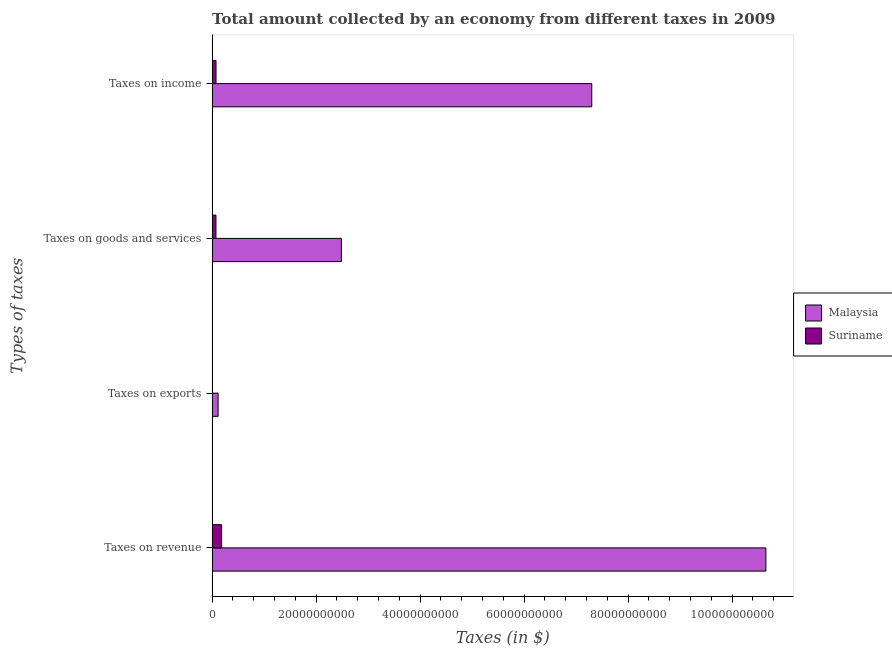How many different coloured bars are there?
Your answer should be compact. 2. How many groups of bars are there?
Make the answer very short. 4. What is the label of the 4th group of bars from the top?
Your answer should be compact. Taxes on revenue. What is the amount collected as tax on revenue in Suriname?
Offer a very short reply. 1.83e+09. Across all countries, what is the maximum amount collected as tax on income?
Make the answer very short. 7.30e+1. Across all countries, what is the minimum amount collected as tax on revenue?
Your answer should be compact. 1.83e+09. In which country was the amount collected as tax on goods maximum?
Provide a short and direct response. Malaysia. In which country was the amount collected as tax on exports minimum?
Provide a succinct answer. Suriname. What is the total amount collected as tax on exports in the graph?
Offer a very short reply. 1.16e+09. What is the difference between the amount collected as tax on goods in Suriname and that in Malaysia?
Provide a short and direct response. -2.41e+1. What is the difference between the amount collected as tax on revenue in Malaysia and the amount collected as tax on exports in Suriname?
Keep it short and to the point. 1.07e+11. What is the average amount collected as tax on goods per country?
Provide a short and direct response. 1.28e+1. What is the difference between the amount collected as tax on exports and amount collected as tax on income in Malaysia?
Provide a short and direct response. -7.19e+1. In how many countries, is the amount collected as tax on income greater than 36000000000 $?
Your answer should be compact. 1. What is the ratio of the amount collected as tax on exports in Malaysia to that in Suriname?
Keep it short and to the point. 269.78. Is the difference between the amount collected as tax on exports in Suriname and Malaysia greater than the difference between the amount collected as tax on goods in Suriname and Malaysia?
Make the answer very short. Yes. What is the difference between the highest and the second highest amount collected as tax on income?
Give a very brief answer. 7.23e+1. What is the difference between the highest and the lowest amount collected as tax on revenue?
Ensure brevity in your answer.  1.05e+11. Is the sum of the amount collected as tax on goods in Malaysia and Suriname greater than the maximum amount collected as tax on revenue across all countries?
Your answer should be compact. No. What does the 1st bar from the top in Taxes on exports represents?
Offer a terse response. Suriname. What does the 1st bar from the bottom in Taxes on exports represents?
Give a very brief answer. Malaysia. Is it the case that in every country, the sum of the amount collected as tax on revenue and amount collected as tax on exports is greater than the amount collected as tax on goods?
Offer a very short reply. Yes. Are all the bars in the graph horizontal?
Give a very brief answer. Yes. Are the values on the major ticks of X-axis written in scientific E-notation?
Provide a succinct answer. No. Does the graph contain any zero values?
Keep it short and to the point. No. How are the legend labels stacked?
Give a very brief answer. Vertical. What is the title of the graph?
Offer a very short reply. Total amount collected by an economy from different taxes in 2009. Does "Belarus" appear as one of the legend labels in the graph?
Offer a very short reply. No. What is the label or title of the X-axis?
Offer a terse response. Taxes (in $). What is the label or title of the Y-axis?
Give a very brief answer. Types of taxes. What is the Taxes (in $) in Malaysia in Taxes on revenue?
Offer a very short reply. 1.07e+11. What is the Taxes (in $) in Suriname in Taxes on revenue?
Offer a terse response. 1.83e+09. What is the Taxes (in $) of Malaysia in Taxes on exports?
Provide a succinct answer. 1.15e+09. What is the Taxes (in $) of Suriname in Taxes on exports?
Keep it short and to the point. 4.27e+06. What is the Taxes (in $) of Malaysia in Taxes on goods and services?
Offer a terse response. 2.49e+1. What is the Taxes (in $) in Suriname in Taxes on goods and services?
Offer a very short reply. 7.38e+08. What is the Taxes (in $) in Malaysia in Taxes on income?
Make the answer very short. 7.30e+1. What is the Taxes (in $) of Suriname in Taxes on income?
Provide a short and direct response. 7.49e+08. Across all Types of taxes, what is the maximum Taxes (in $) of Malaysia?
Your answer should be very brief. 1.07e+11. Across all Types of taxes, what is the maximum Taxes (in $) of Suriname?
Make the answer very short. 1.83e+09. Across all Types of taxes, what is the minimum Taxes (in $) of Malaysia?
Make the answer very short. 1.15e+09. Across all Types of taxes, what is the minimum Taxes (in $) of Suriname?
Your answer should be compact. 4.27e+06. What is the total Taxes (in $) of Malaysia in the graph?
Provide a succinct answer. 2.06e+11. What is the total Taxes (in $) of Suriname in the graph?
Provide a short and direct response. 3.32e+09. What is the difference between the Taxes (in $) of Malaysia in Taxes on revenue and that in Taxes on exports?
Your response must be concise. 1.05e+11. What is the difference between the Taxes (in $) in Suriname in Taxes on revenue and that in Taxes on exports?
Offer a terse response. 1.83e+09. What is the difference between the Taxes (in $) in Malaysia in Taxes on revenue and that in Taxes on goods and services?
Provide a succinct answer. 8.16e+1. What is the difference between the Taxes (in $) of Suriname in Taxes on revenue and that in Taxes on goods and services?
Your answer should be very brief. 1.09e+09. What is the difference between the Taxes (in $) in Malaysia in Taxes on revenue and that in Taxes on income?
Your answer should be very brief. 3.35e+1. What is the difference between the Taxes (in $) of Suriname in Taxes on revenue and that in Taxes on income?
Offer a very short reply. 1.08e+09. What is the difference between the Taxes (in $) in Malaysia in Taxes on exports and that in Taxes on goods and services?
Ensure brevity in your answer.  -2.37e+1. What is the difference between the Taxes (in $) in Suriname in Taxes on exports and that in Taxes on goods and services?
Offer a very short reply. -7.33e+08. What is the difference between the Taxes (in $) of Malaysia in Taxes on exports and that in Taxes on income?
Make the answer very short. -7.19e+1. What is the difference between the Taxes (in $) in Suriname in Taxes on exports and that in Taxes on income?
Keep it short and to the point. -7.45e+08. What is the difference between the Taxes (in $) of Malaysia in Taxes on goods and services and that in Taxes on income?
Offer a terse response. -4.82e+1. What is the difference between the Taxes (in $) in Suriname in Taxes on goods and services and that in Taxes on income?
Your answer should be compact. -1.17e+07. What is the difference between the Taxes (in $) in Malaysia in Taxes on revenue and the Taxes (in $) in Suriname in Taxes on exports?
Keep it short and to the point. 1.07e+11. What is the difference between the Taxes (in $) in Malaysia in Taxes on revenue and the Taxes (in $) in Suriname in Taxes on goods and services?
Your response must be concise. 1.06e+11. What is the difference between the Taxes (in $) of Malaysia in Taxes on revenue and the Taxes (in $) of Suriname in Taxes on income?
Offer a terse response. 1.06e+11. What is the difference between the Taxes (in $) in Malaysia in Taxes on exports and the Taxes (in $) in Suriname in Taxes on goods and services?
Your answer should be very brief. 4.14e+08. What is the difference between the Taxes (in $) of Malaysia in Taxes on exports and the Taxes (in $) of Suriname in Taxes on income?
Provide a succinct answer. 4.03e+08. What is the difference between the Taxes (in $) of Malaysia in Taxes on goods and services and the Taxes (in $) of Suriname in Taxes on income?
Your answer should be very brief. 2.41e+1. What is the average Taxes (in $) of Malaysia per Types of taxes?
Provide a succinct answer. 5.14e+1. What is the average Taxes (in $) in Suriname per Types of taxes?
Keep it short and to the point. 8.31e+08. What is the difference between the Taxes (in $) in Malaysia and Taxes (in $) in Suriname in Taxes on revenue?
Provide a short and direct response. 1.05e+11. What is the difference between the Taxes (in $) in Malaysia and Taxes (in $) in Suriname in Taxes on exports?
Provide a succinct answer. 1.15e+09. What is the difference between the Taxes (in $) of Malaysia and Taxes (in $) of Suriname in Taxes on goods and services?
Provide a succinct answer. 2.41e+1. What is the difference between the Taxes (in $) in Malaysia and Taxes (in $) in Suriname in Taxes on income?
Offer a very short reply. 7.23e+1. What is the ratio of the Taxes (in $) of Malaysia in Taxes on revenue to that in Taxes on exports?
Your answer should be very brief. 92.44. What is the ratio of the Taxes (in $) of Suriname in Taxes on revenue to that in Taxes on exports?
Provide a short and direct response. 428.91. What is the ratio of the Taxes (in $) of Malaysia in Taxes on revenue to that in Taxes on goods and services?
Offer a very short reply. 4.28. What is the ratio of the Taxes (in $) in Suriname in Taxes on revenue to that in Taxes on goods and services?
Ensure brevity in your answer.  2.48. What is the ratio of the Taxes (in $) in Malaysia in Taxes on revenue to that in Taxes on income?
Your response must be concise. 1.46. What is the ratio of the Taxes (in $) of Suriname in Taxes on revenue to that in Taxes on income?
Your answer should be compact. 2.44. What is the ratio of the Taxes (in $) in Malaysia in Taxes on exports to that in Taxes on goods and services?
Provide a succinct answer. 0.05. What is the ratio of the Taxes (in $) in Suriname in Taxes on exports to that in Taxes on goods and services?
Provide a short and direct response. 0.01. What is the ratio of the Taxes (in $) of Malaysia in Taxes on exports to that in Taxes on income?
Your answer should be compact. 0.02. What is the ratio of the Taxes (in $) of Suriname in Taxes on exports to that in Taxes on income?
Your answer should be compact. 0.01. What is the ratio of the Taxes (in $) in Malaysia in Taxes on goods and services to that in Taxes on income?
Provide a short and direct response. 0.34. What is the ratio of the Taxes (in $) in Suriname in Taxes on goods and services to that in Taxes on income?
Make the answer very short. 0.98. What is the difference between the highest and the second highest Taxes (in $) of Malaysia?
Ensure brevity in your answer.  3.35e+1. What is the difference between the highest and the second highest Taxes (in $) in Suriname?
Give a very brief answer. 1.08e+09. What is the difference between the highest and the lowest Taxes (in $) of Malaysia?
Provide a succinct answer. 1.05e+11. What is the difference between the highest and the lowest Taxes (in $) in Suriname?
Your answer should be compact. 1.83e+09. 